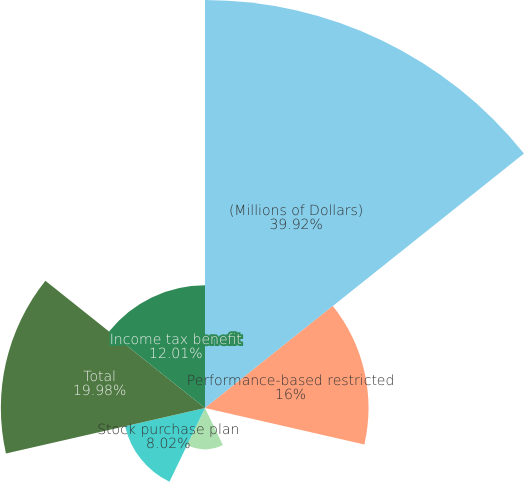Convert chart. <chart><loc_0><loc_0><loc_500><loc_500><pie_chart><fcel>(Millions of Dollars)<fcel>Performance-based restricted<fcel>Time-based restricted stock<fcel>Non-employee director deferred<fcel>Stock purchase plan<fcel>Total<fcel>Income tax benefit<nl><fcel>39.93%<fcel>16.0%<fcel>0.04%<fcel>4.03%<fcel>8.02%<fcel>19.98%<fcel>12.01%<nl></chart> 